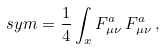<formula> <loc_0><loc_0><loc_500><loc_500>\ s y m = \frac { 1 } { 4 } \int _ { x } F _ { \mu \nu } ^ { a } \, F _ { \mu \nu } ^ { a } \, ,</formula> 